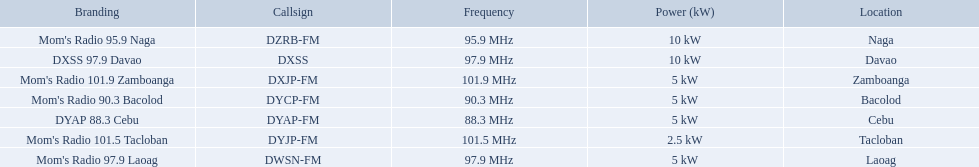What brandings have a power of 5 kw? Mom's Radio 97.9 Laoag, Mom's Radio 90.3 Bacolod, DYAP 88.3 Cebu, Mom's Radio 101.9 Zamboanga. Which of these has a call-sign beginning with dy? Mom's Radio 90.3 Bacolod, DYAP 88.3 Cebu. Which of those uses the lowest frequency? DYAP 88.3 Cebu. Which stations use less than 10kw of power? Mom's Radio 97.9 Laoag, Mom's Radio 90.3 Bacolod, DYAP 88.3 Cebu, Mom's Radio 101.5 Tacloban, Mom's Radio 101.9 Zamboanga. Do any stations use less than 5kw of power? if so, which ones? Mom's Radio 101.5 Tacloban. 